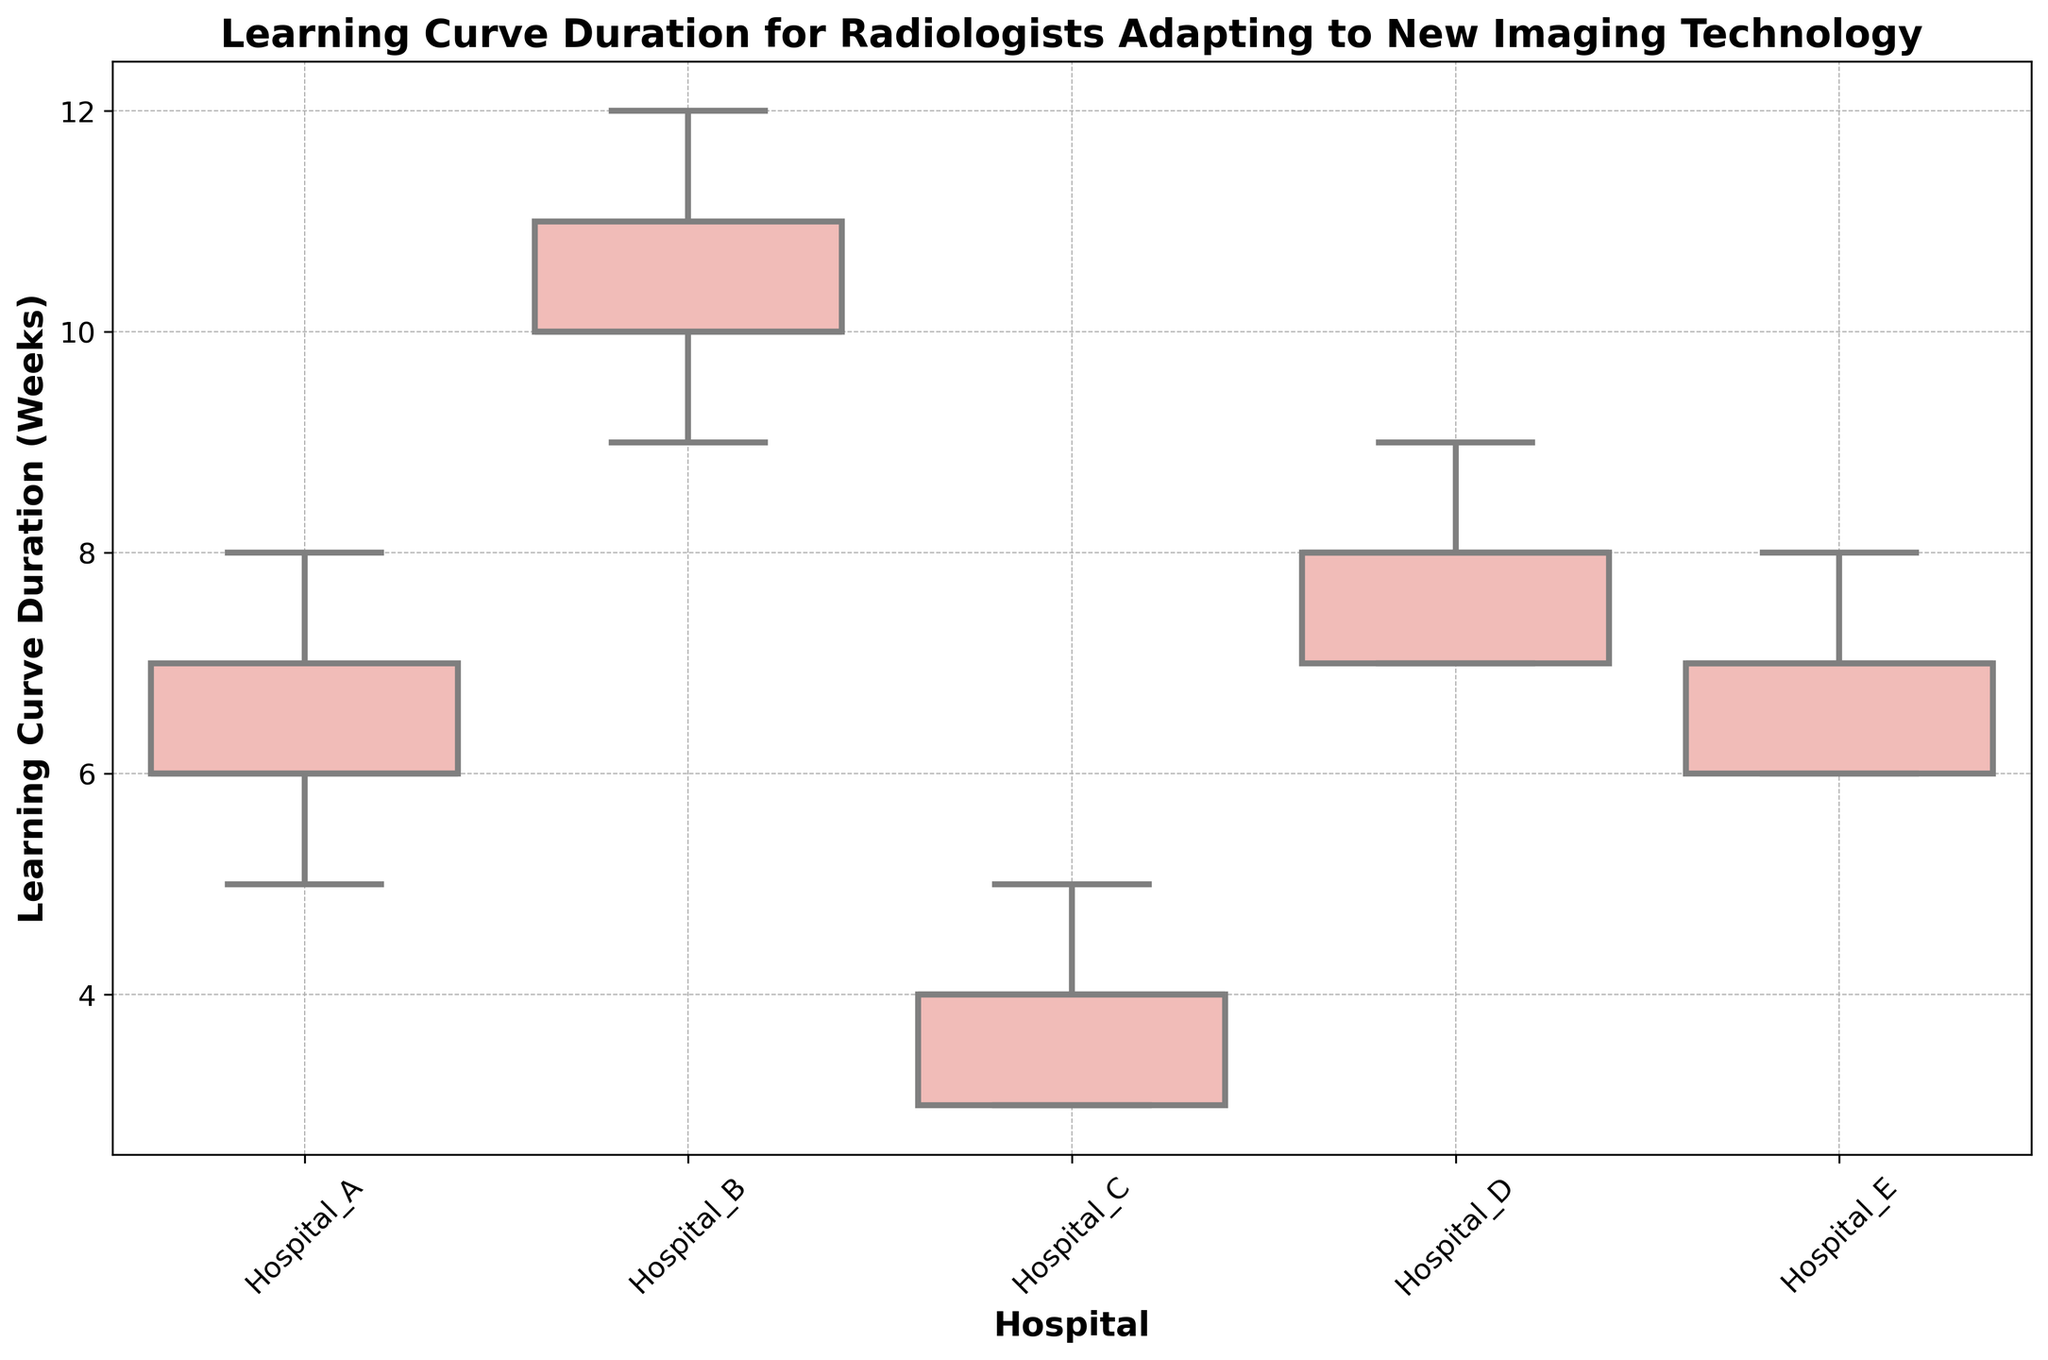What's the median learning curve duration for Hospital B? To find the median, sort the durations {9, 10, 10, 11, 12}. The middle value is 10.
Answer: 10 Which hospital has the longest interquartile range (IQR) for learning curve duration? The IQR is the range between the first and third quartiles (Q1 and Q3). Visually, Hospital B has the widest box, indicating the largest IQR.
Answer: Hospital B What is the range of learning curve durations for Hospital C? The range is the difference between the maximum and minimum values. For Hospital C, the minimum is 3 and the maximum is 5, so the range is 5 - 3 = 2 weeks.
Answer: 2 weeks Which hospital has the shortest median learning curve duration? Visually, the line inside the box represents the median. The shortest one is in Hospital C.
Answer: Hospital C Compare the learning curve duration distributions between Hospital D and Hospital E. Both Hospital D and Hospital E have similar medians and IQRs, but Hospital D shows slightly more variability in the whiskers.
Answer: Similar, but Hospital D is slightly more variable Which hospital has the most outliers? Outliers are typically represented as individual points outside the whiskers. None of the hospitals have outliers in this box plot.
Answer: None What is the overall learning curve duration range for Hospital A? For Hospital A, the minimum is 5 weeks and the maximum is 8 weeks, thus the range is 8 - 5 = 3 weeks.
Answer: 3 weeks Is the variability in learning curve duration higher in Hospital B than in Hospital A? Yes, the variability (represented by the box and whisker lengths) is much higher in Hospital B as its box and whiskers are longer compared to Hospital A.
Answer: Yes What's the combined average median learning curve duration for Hospitals A and B? The medians are 6.5 for A (average of 6 and 7) and 10 for B. The combined average is (6.5 + 10) / 2 = 8.25 weeks.
Answer: 8.25 weeks 